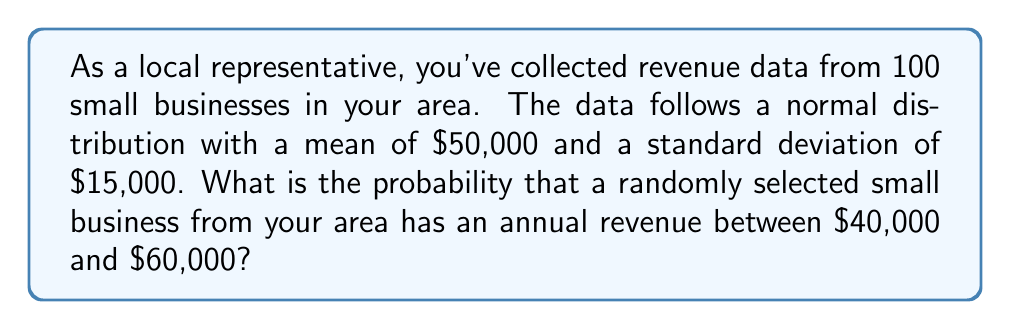Help me with this question. To solve this problem, we'll use the properties of the normal distribution and the concept of z-scores.

Step 1: Calculate the z-scores for the lower and upper bounds of the revenue range.

Z-score formula: $z = \frac{x - \mu}{\sigma}$

Where:
$x$ = value of interest
$\mu$ = mean
$\sigma$ = standard deviation

For $40,000:
z_1 = \frac{40000 - 50000}{15000} = -\frac{10000}{15000} = -0.67$

For $60,000:
z_2 = \frac{60000 - 50000}{15000} = \frac{10000}{15000} = 0.67$

Step 2: Use a standard normal distribution table or calculator to find the area under the curve between these z-scores.

The probability is equal to the area between $z_1$ and $z_2$.

$P(-0.67 < Z < 0.67) = P(Z < 0.67) - P(Z < -0.67)$

Using a standard normal table or calculator:

$P(Z < 0.67) = 0.7486$
$P(Z < -0.67) = 0.2514$

$P(-0.67 < Z < 0.67) = 0.7486 - 0.2514 = 0.4972$

Step 3: Convert the probability to a percentage.

$0.4972 \times 100\% = 49.72\%$

Therefore, the probability that a randomly selected small business from your area has an annual revenue between $40,000 and $60,000 is approximately 49.72%.
Answer: 49.72% 